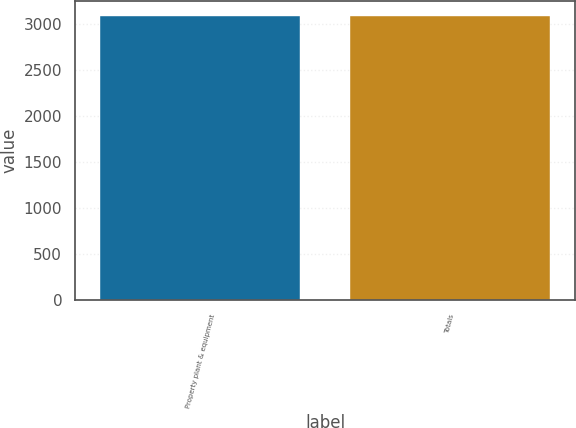Convert chart to OTSL. <chart><loc_0><loc_0><loc_500><loc_500><bar_chart><fcel>Property plant & equipment<fcel>Totals<nl><fcel>3095<fcel>3095.1<nl></chart> 